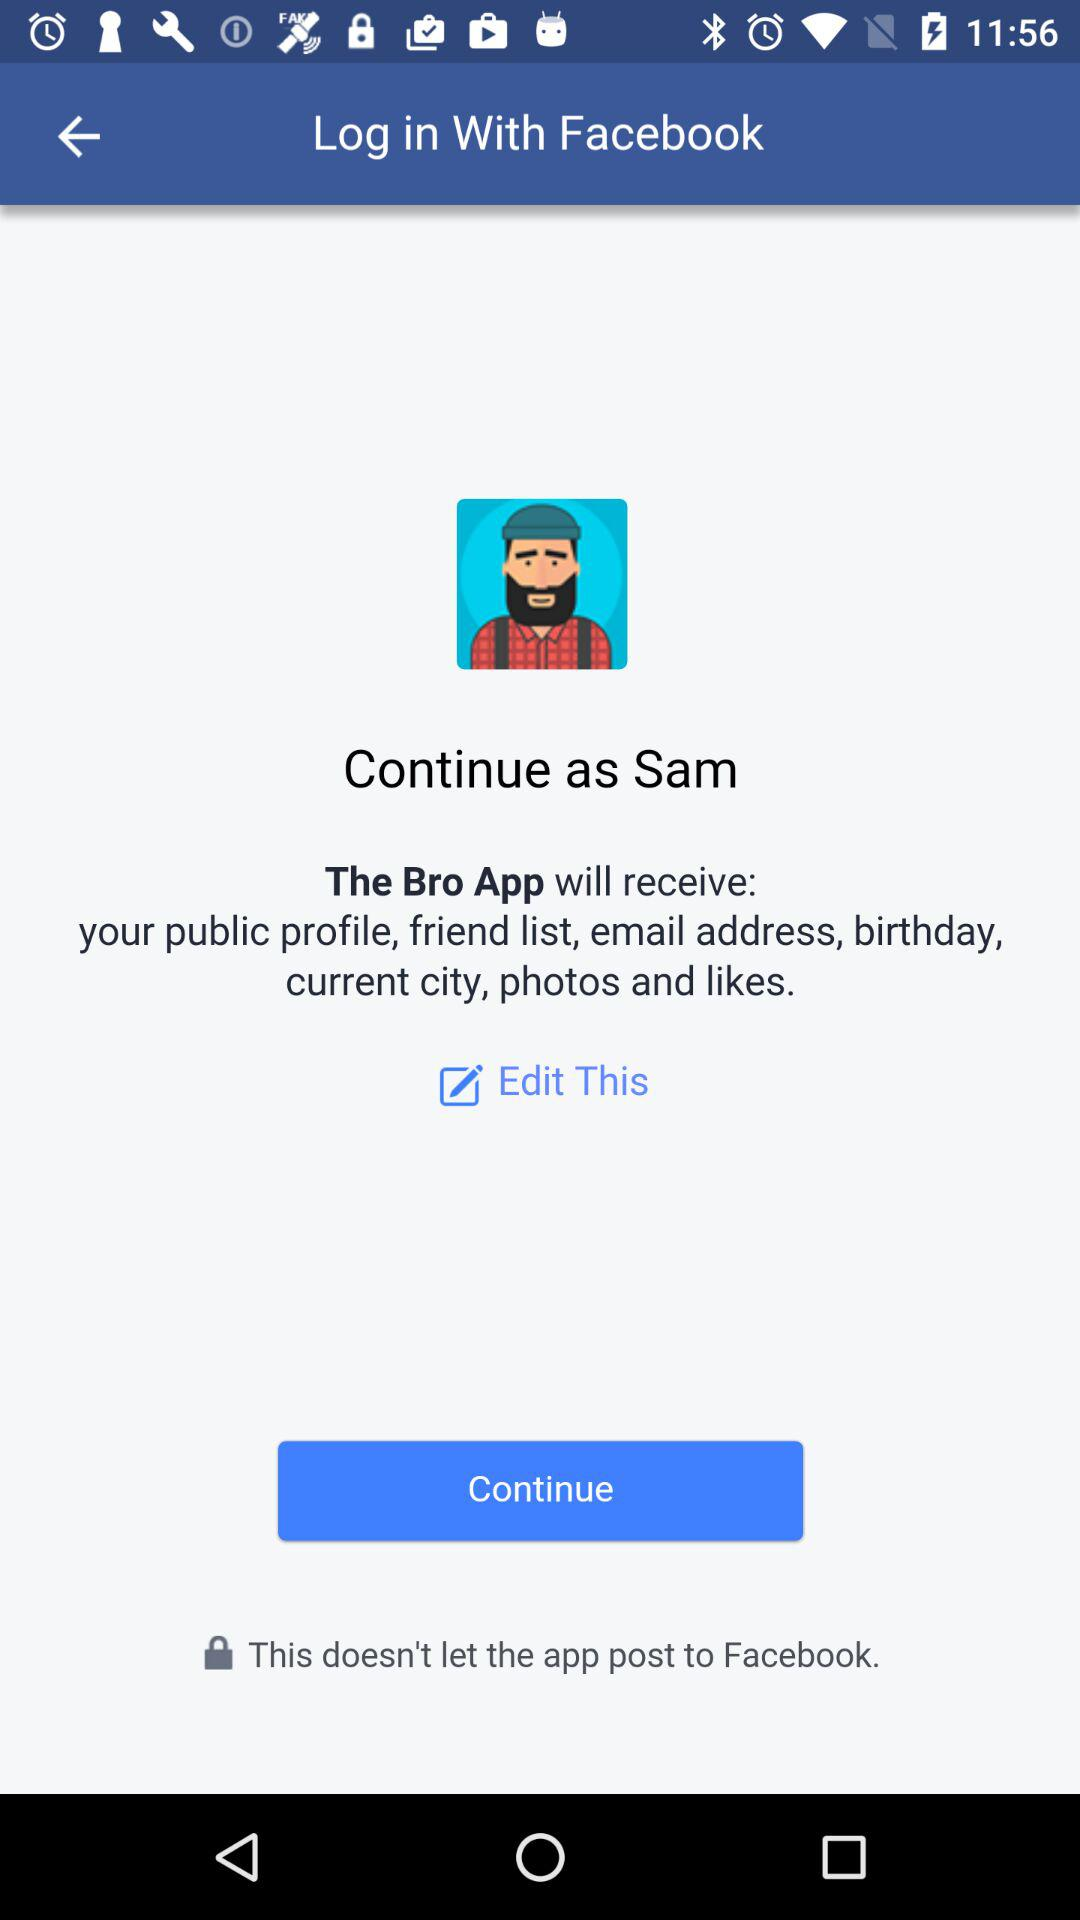What application is asking for permission? The application asking for permission is "The Bro App". 